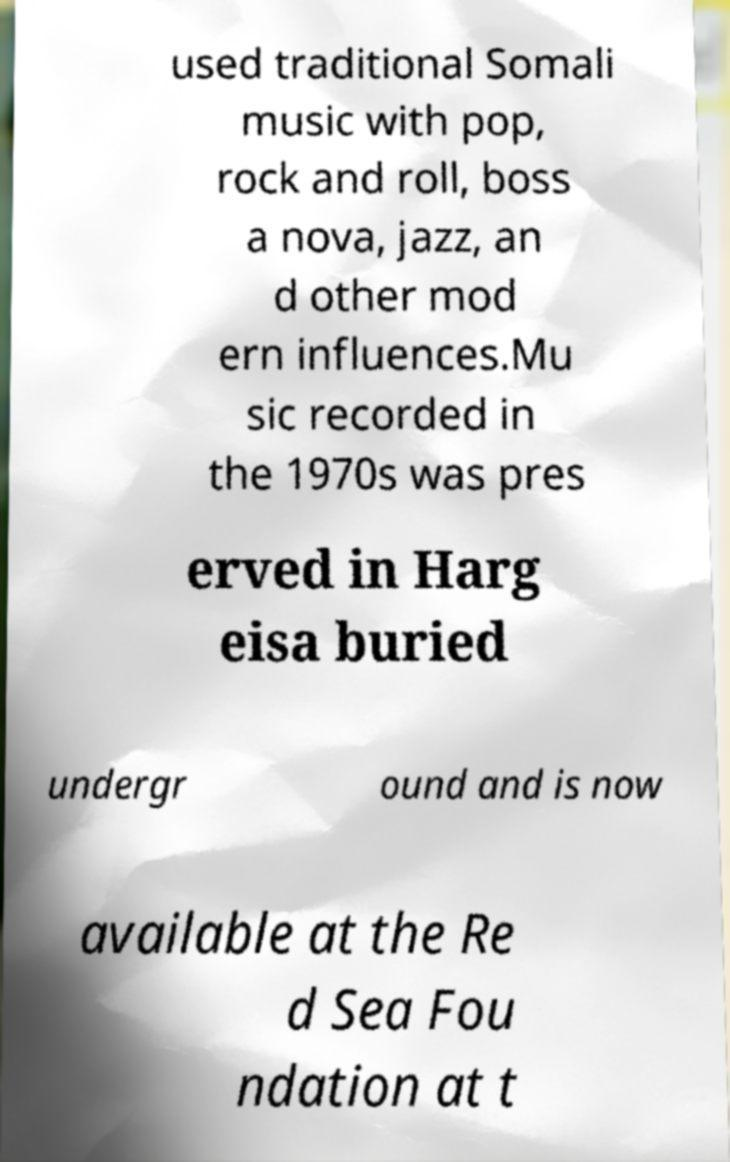Could you extract and type out the text from this image? used traditional Somali music with pop, rock and roll, boss a nova, jazz, an d other mod ern influences.Mu sic recorded in the 1970s was pres erved in Harg eisa buried undergr ound and is now available at the Re d Sea Fou ndation at t 